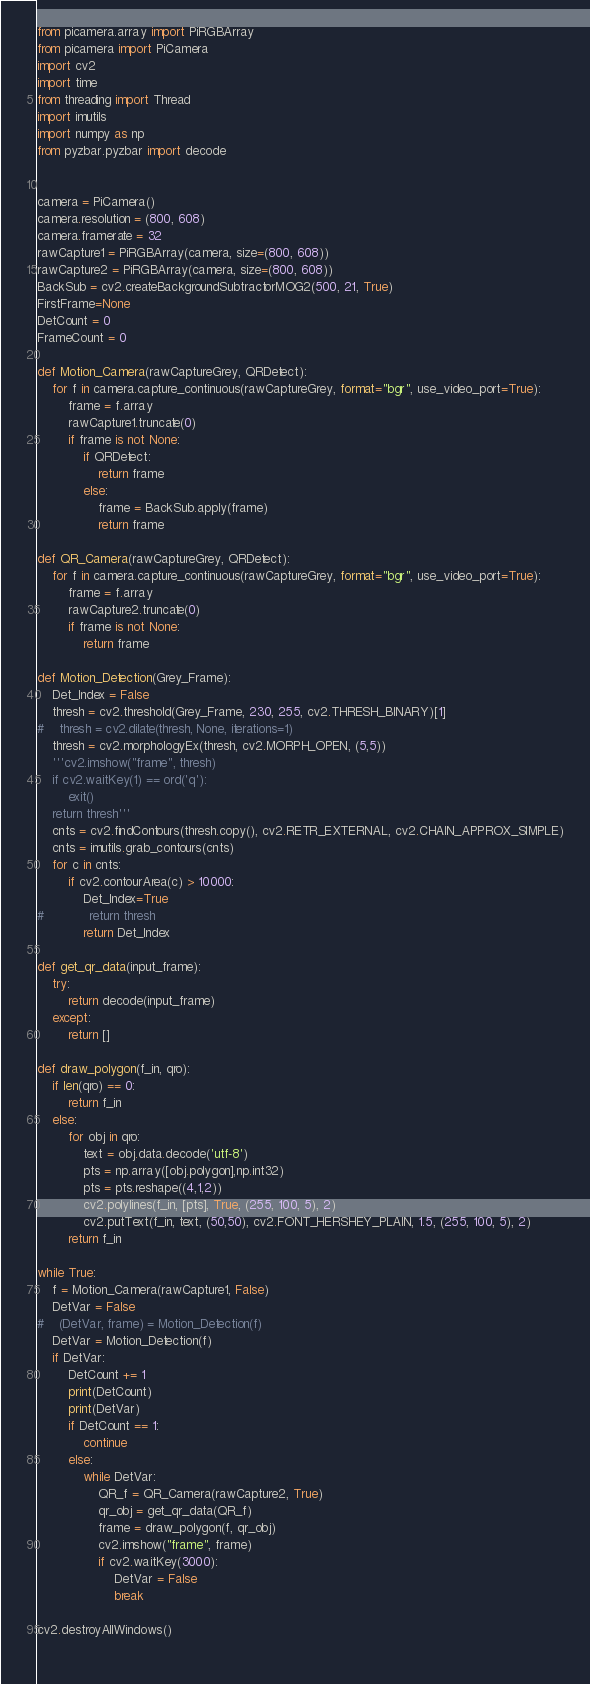<code> <loc_0><loc_0><loc_500><loc_500><_Python_>from picamera.array import PiRGBArray
from picamera import PiCamera
import cv2
import time
from threading import Thread
import imutils
import numpy as np
from pyzbar.pyzbar import decode


camera = PiCamera()
camera.resolution = (800, 608)
camera.framerate = 32
rawCapture1 = PiRGBArray(camera, size=(800, 608))
rawCapture2 = PiRGBArray(camera, size=(800, 608))
BackSub = cv2.createBackgroundSubtractorMOG2(500, 21, True)
FirstFrame=None
DetCount = 0
FrameCount = 0

def Motion_Camera(rawCaptureGrey, QRDetect):
    for f in camera.capture_continuous(rawCaptureGrey, format="bgr", use_video_port=True):
        frame = f.array
        rawCapture1.truncate(0)
        if frame is not None:
            if QRDetect:
                return frame
            else:
                frame = BackSub.apply(frame)
                return frame
            
def QR_Camera(rawCaptureGrey, QRDetect):
    for f in camera.capture_continuous(rawCaptureGrey, format="bgr", use_video_port=True):
        frame = f.array
        rawCapture2.truncate(0)
        if frame is not None:
            return frame

def Motion_Detection(Grey_Frame):
    Det_Index = False
    thresh = cv2.threshold(Grey_Frame, 230, 255, cv2.THRESH_BINARY)[1]
#    thresh = cv2.dilate(thresh, None, iterations=1)
    thresh = cv2.morphologyEx(thresh, cv2.MORPH_OPEN, (5,5))
    '''cv2.imshow("frame", thresh)
    if cv2.waitKey(1) == ord('q'):
        exit()
    return thresh'''
    cnts = cv2.findContours(thresh.copy(), cv2.RETR_EXTERNAL, cv2.CHAIN_APPROX_SIMPLE)
    cnts = imutils.grab_contours(cnts)
    for c in cnts:
        if cv2.contourArea(c) > 10000:
            Det_Index=True
#            return thresh
            return Det_Index
        
def get_qr_data(input_frame):
    try:
        return decode(input_frame)
    except:
        return []

def draw_polygon(f_in, qro):
    if len(qro) == 0:
        return f_in
    else:
        for obj in qro:
            text = obj.data.decode('utf-8')
            pts = np.array([obj.polygon],np.int32)
            pts = pts.reshape((4,1,2))
            cv2.polylines(f_in, [pts], True, (255, 100, 5), 2)
            cv2.putText(f_in, text, (50,50), cv2.FONT_HERSHEY_PLAIN, 1.5, (255, 100, 5), 2)
        return f_in

while True:
    f = Motion_Camera(rawCapture1, False)
    DetVar = False
#    (DetVar, frame) = Motion_Detection(f)
    DetVar = Motion_Detection(f)
    if DetVar:
        DetCount += 1
        print(DetCount)
        print(DetVar)
        if DetCount == 1:
            continue
        else:
            while DetVar:
                QR_f = QR_Camera(rawCapture2, True)
                qr_obj = get_qr_data(QR_f)
                frame = draw_polygon(f, qr_obj)
                cv2.imshow("frame", frame)
                if cv2.waitKey(3000):
                    DetVar = False
                    break

cv2.destroyAllWindows()
    

</code> 